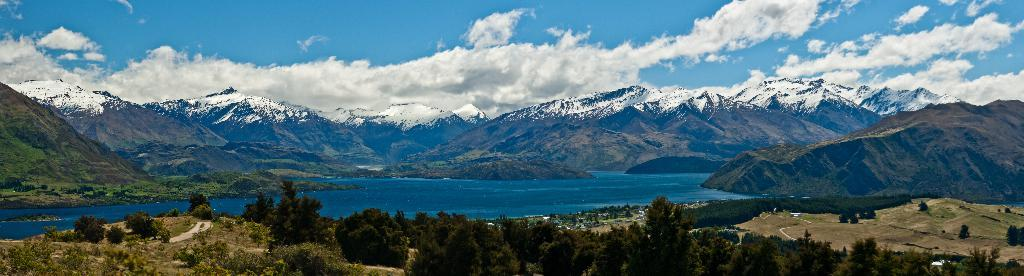What type of natural landscape is depicted in the image? The image features mountains, a river, and trees. Can you describe the sky in the image? The sky is clear in the image. Can you tell me how many airplanes are flying over the mountains in the image? There are no airplanes visible in the image; it only features mountains, a river, trees, and a clear sky. What achievements has the cellar accomplished in the image? There is no cellar present in the image, and therefore no achievements can be attributed to it. 